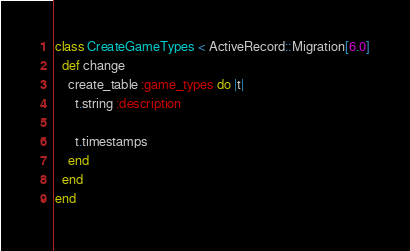Convert code to text. <code><loc_0><loc_0><loc_500><loc_500><_Ruby_>class CreateGameTypes < ActiveRecord::Migration[6.0]
  def change
    create_table :game_types do |t|
      t.string :description

      t.timestamps
    end
  end
end
</code> 